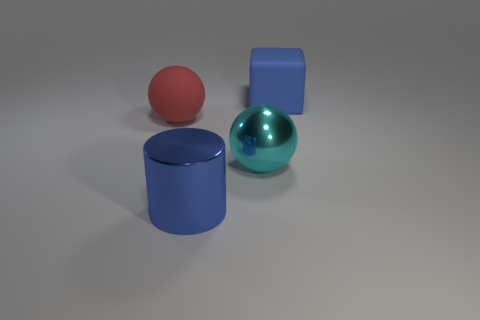The other thing that is the same shape as the cyan metallic thing is what size?
Your answer should be compact. Large. Are there any big blue matte objects?
Give a very brief answer. Yes. How many objects are either blocks that are to the right of the big cyan metal ball or purple metal spheres?
Provide a short and direct response. 1. What material is the block that is the same size as the cyan sphere?
Offer a terse response. Rubber. The rubber thing that is right of the big thing in front of the metal ball is what color?
Provide a short and direct response. Blue. There is a big blue metallic object; what number of blue cylinders are in front of it?
Your answer should be very brief. 0. What is the color of the metal sphere?
Keep it short and to the point. Cyan. What number of large objects are spheres or blue rubber balls?
Keep it short and to the point. 2. Do the sphere to the left of the cyan metal thing and the sphere right of the large blue metallic object have the same color?
Provide a succinct answer. No. How many other things are the same color as the metal ball?
Your response must be concise. 0. 